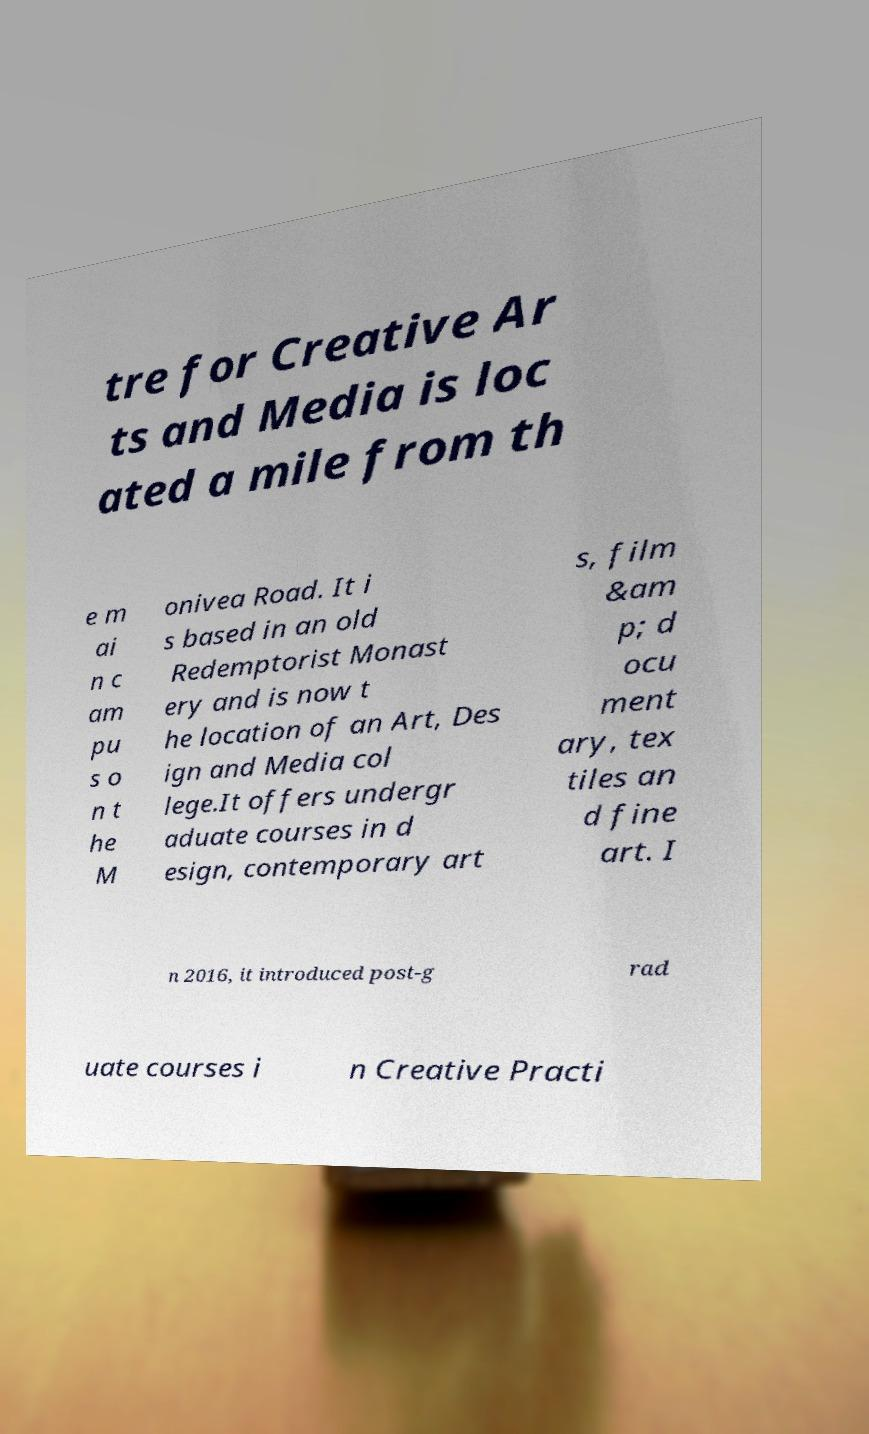I need the written content from this picture converted into text. Can you do that? tre for Creative Ar ts and Media is loc ated a mile from th e m ai n c am pu s o n t he M onivea Road. It i s based in an old Redemptorist Monast ery and is now t he location of an Art, Des ign and Media col lege.It offers undergr aduate courses in d esign, contemporary art s, film &am p; d ocu ment ary, tex tiles an d fine art. I n 2016, it introduced post-g rad uate courses i n Creative Practi 